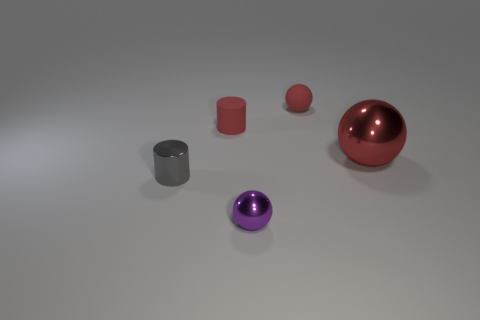Is there a tiny gray object that is to the right of the small cylinder that is to the right of the small metal thing behind the purple sphere?
Keep it short and to the point. No. What number of purple metallic objects are the same size as the purple sphere?
Your response must be concise. 0. Is the size of the ball that is in front of the large sphere the same as the matte thing that is on the right side of the purple metal object?
Ensure brevity in your answer.  Yes. The metallic object that is both to the left of the large red shiny sphere and behind the purple thing has what shape?
Keep it short and to the point. Cylinder. Are there any metal cylinders that have the same color as the small metal sphere?
Offer a very short reply. No. Are any large yellow rubber cubes visible?
Provide a short and direct response. No. What is the color of the shiny sphere in front of the gray thing?
Offer a terse response. Purple. There is a red matte cylinder; is its size the same as the cylinder that is to the left of the red cylinder?
Ensure brevity in your answer.  Yes. What is the size of the object that is both in front of the big red metal thing and on the left side of the small metallic ball?
Give a very brief answer. Small. Is there a purple sphere that has the same material as the small gray thing?
Ensure brevity in your answer.  Yes. 